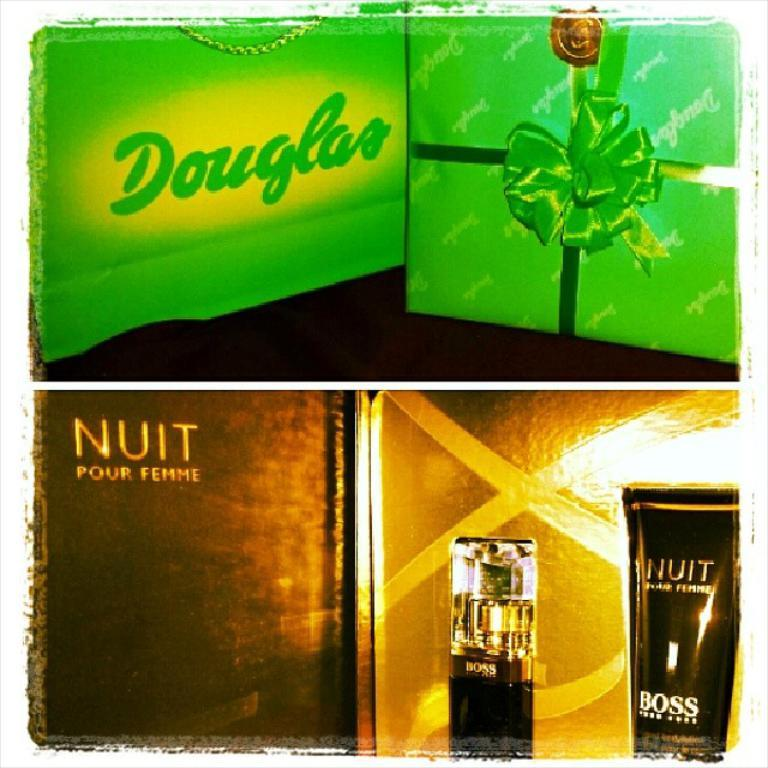Provide a one-sentence caption for the provided image. Hugo Boss Nuit perfume is shown below a green douglas sign. 